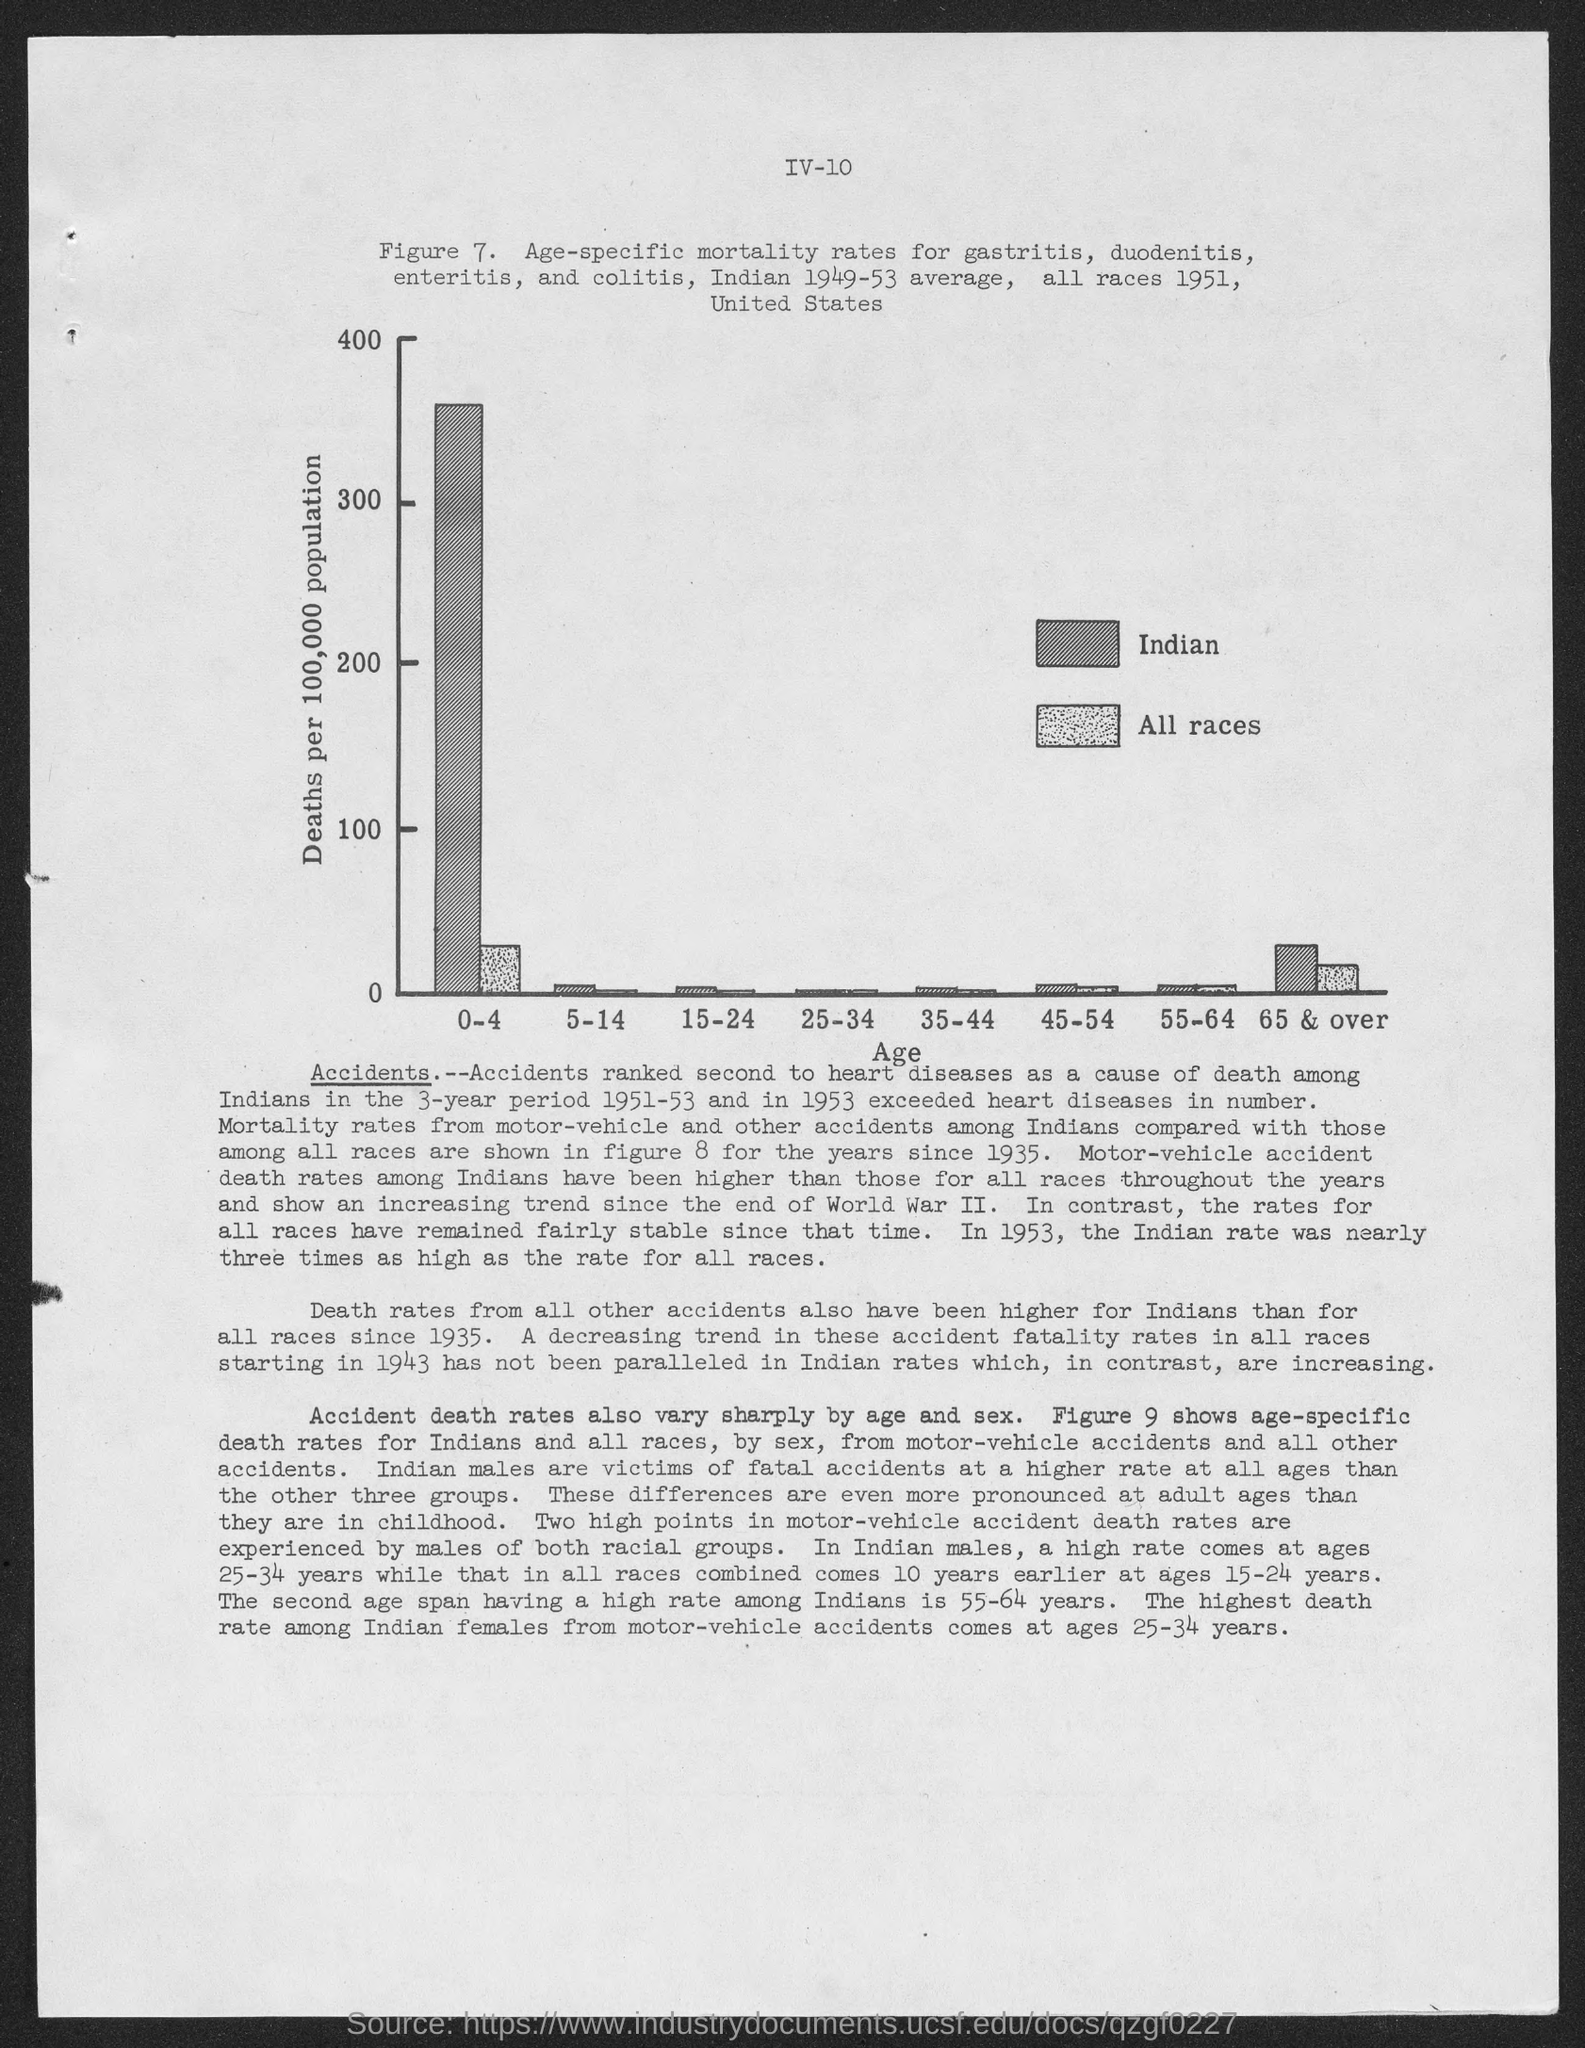Give some essential details in this illustration. The lightly shaded bar in the bar chart represents all races. The dark shaded bar in the bar chart represents India's total imports of goods and services from all countries in 2019. The bar chart shows the rate of deaths per 100,000 population in different countries. The bar chart shows the distribution of ages of people who participated in a survey, with age ranges represented by bars of different heights. The X-axis label is "Age," indicating that the horizontal axis represents age values. 